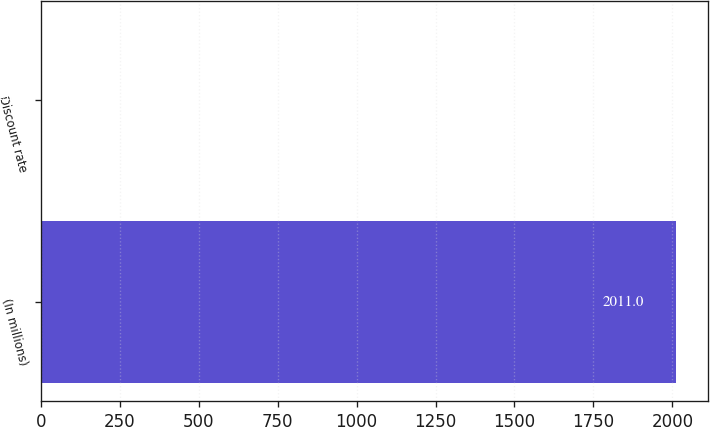Convert chart. <chart><loc_0><loc_0><loc_500><loc_500><bar_chart><fcel>(In millions)<fcel>Discount rate<nl><fcel>2011<fcel>5.44<nl></chart> 